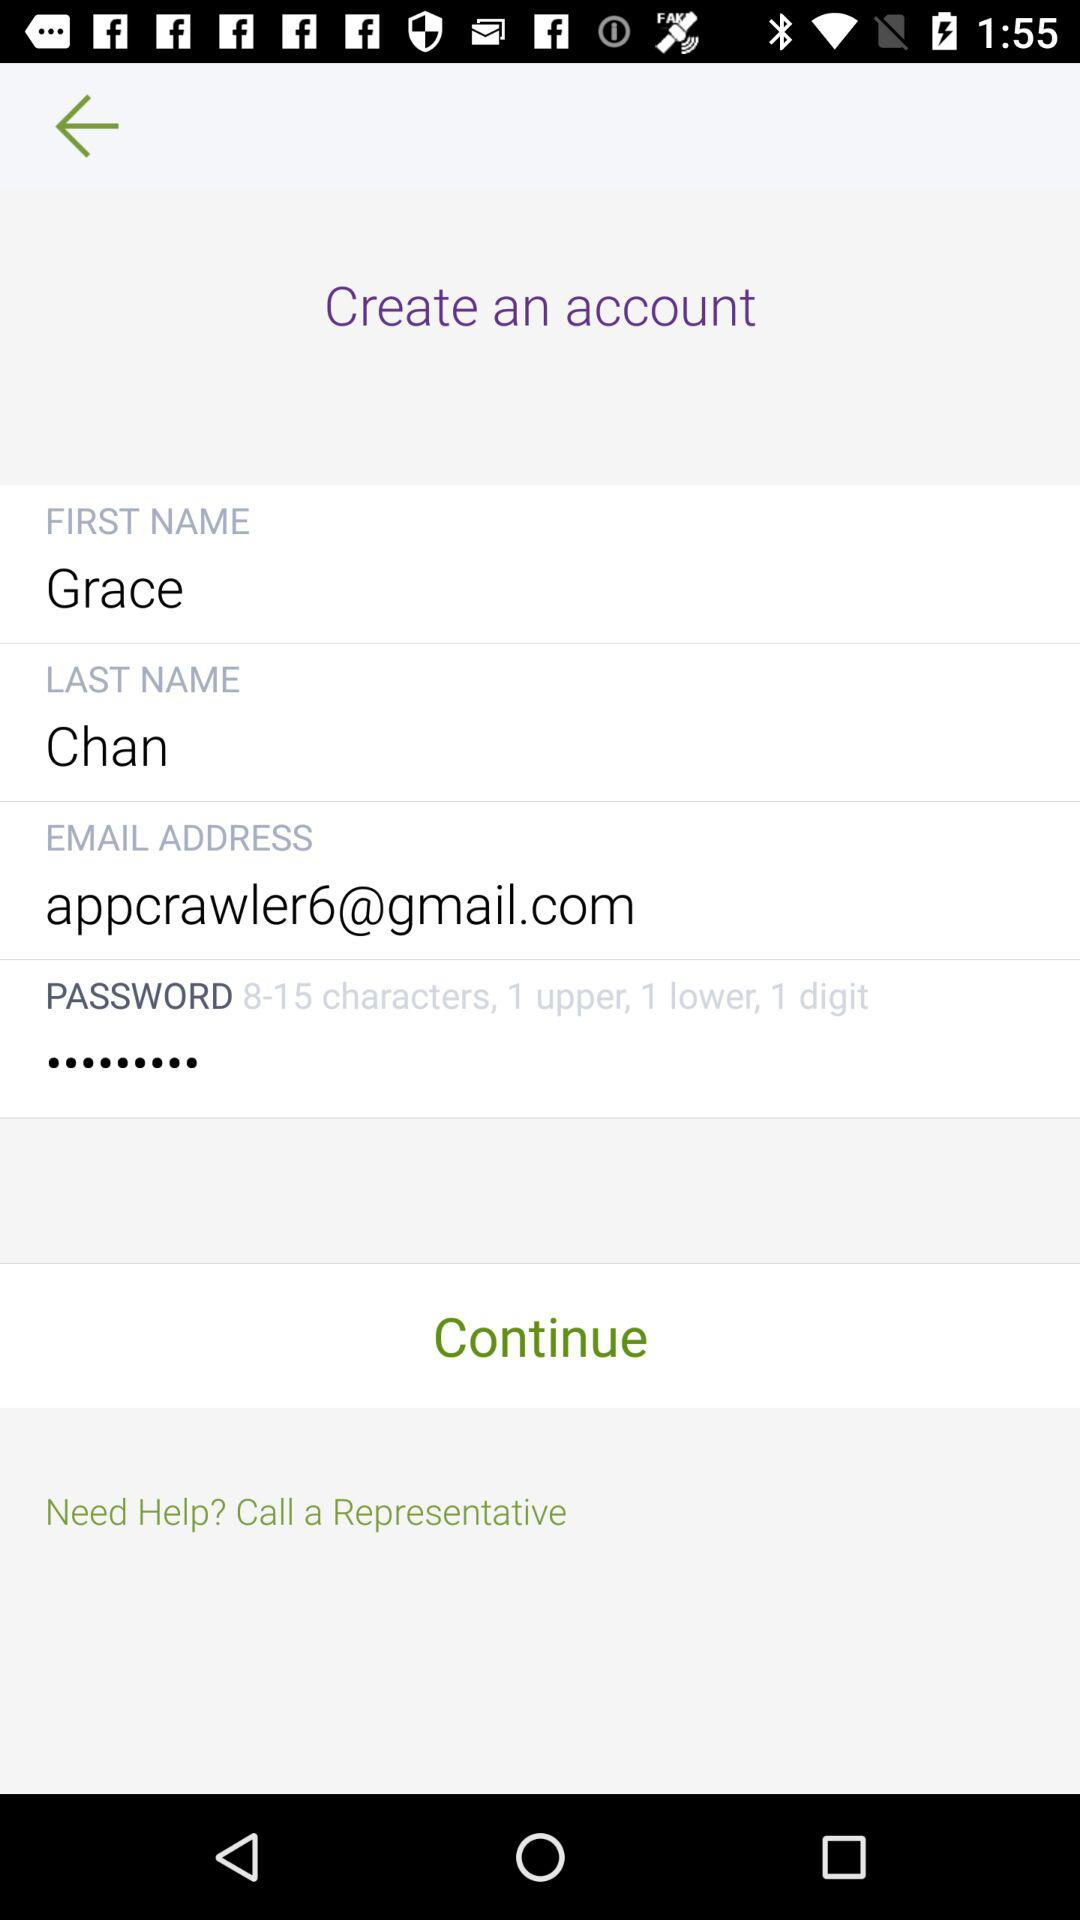What is the email address? The email address is appcrawler6@gmail.com. 